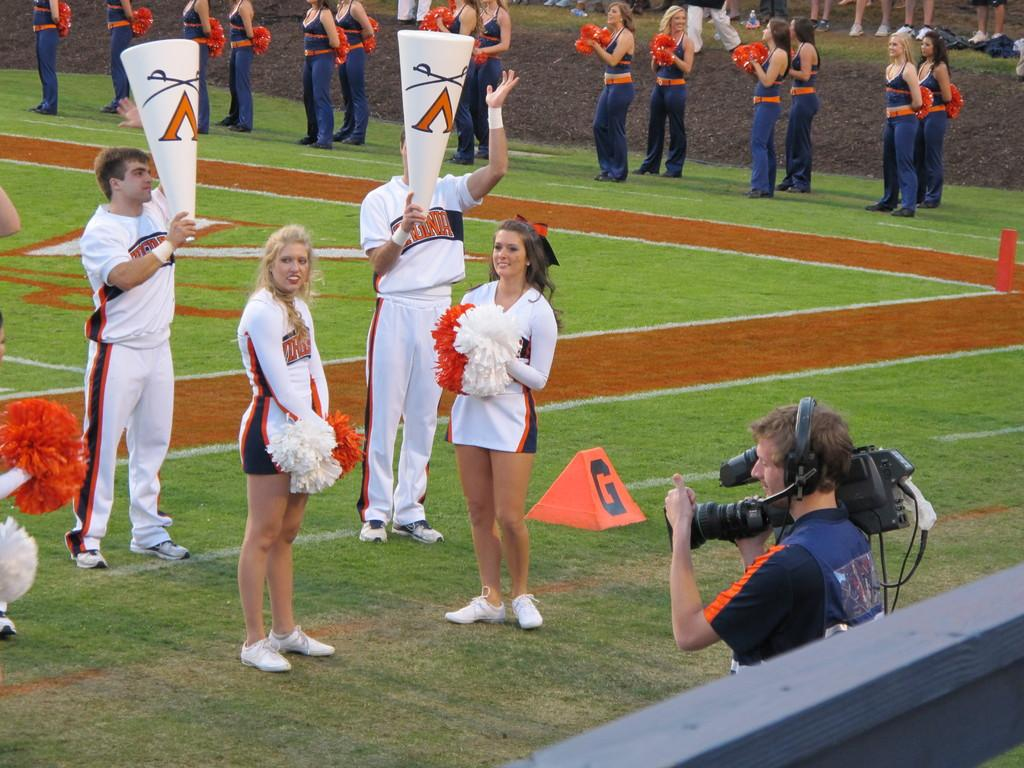Provide a one-sentence caption for the provided image. The cheer leaders stand on the field with a red block with the letter G on it. 